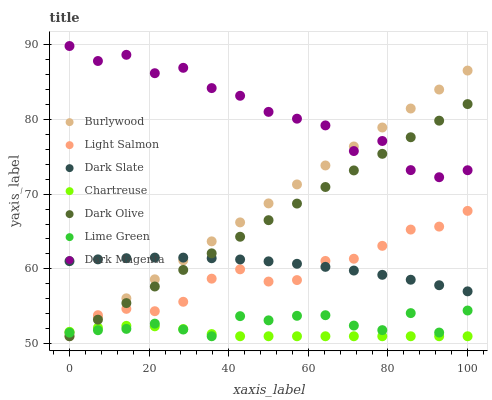Does Chartreuse have the minimum area under the curve?
Answer yes or no. Yes. Does Dark Magenta have the maximum area under the curve?
Answer yes or no. Yes. Does Burlywood have the minimum area under the curve?
Answer yes or no. No. Does Burlywood have the maximum area under the curve?
Answer yes or no. No. Is Dark Olive the smoothest?
Answer yes or no. Yes. Is Dark Magenta the roughest?
Answer yes or no. Yes. Is Burlywood the smoothest?
Answer yes or no. No. Is Burlywood the roughest?
Answer yes or no. No. Does Burlywood have the lowest value?
Answer yes or no. Yes. Does Dark Magenta have the lowest value?
Answer yes or no. No. Does Dark Magenta have the highest value?
Answer yes or no. Yes. Does Burlywood have the highest value?
Answer yes or no. No. Is Lime Green less than Dark Slate?
Answer yes or no. Yes. Is Dark Magenta greater than Light Salmon?
Answer yes or no. Yes. Does Chartreuse intersect Burlywood?
Answer yes or no. Yes. Is Chartreuse less than Burlywood?
Answer yes or no. No. Is Chartreuse greater than Burlywood?
Answer yes or no. No. Does Lime Green intersect Dark Slate?
Answer yes or no. No. 